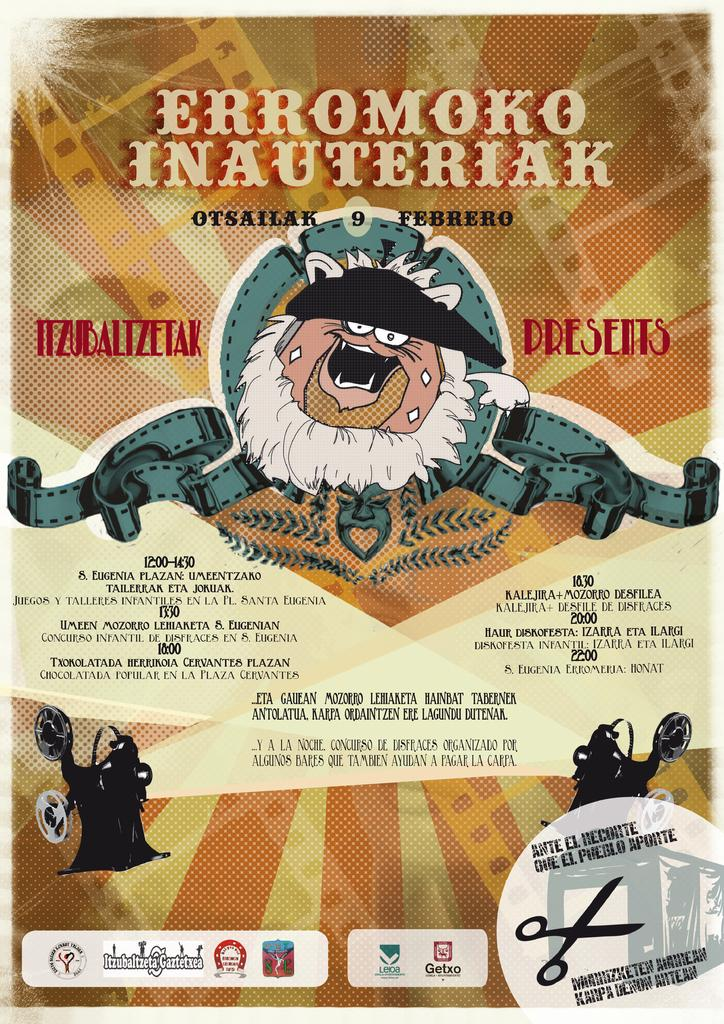What is present on the poster in the image? There is a poster in the image. What types of elements can be seen on the poster? The poster contains alphabets and numbers. What type of treatment is being offered on the poster? There is no indication of any treatment being offered on the poster; it only contains alphabets and numbers. What type of peace symbol can be seen on the poster? There is no peace symbol present on the poster; it only contains alphabets and numbers. 